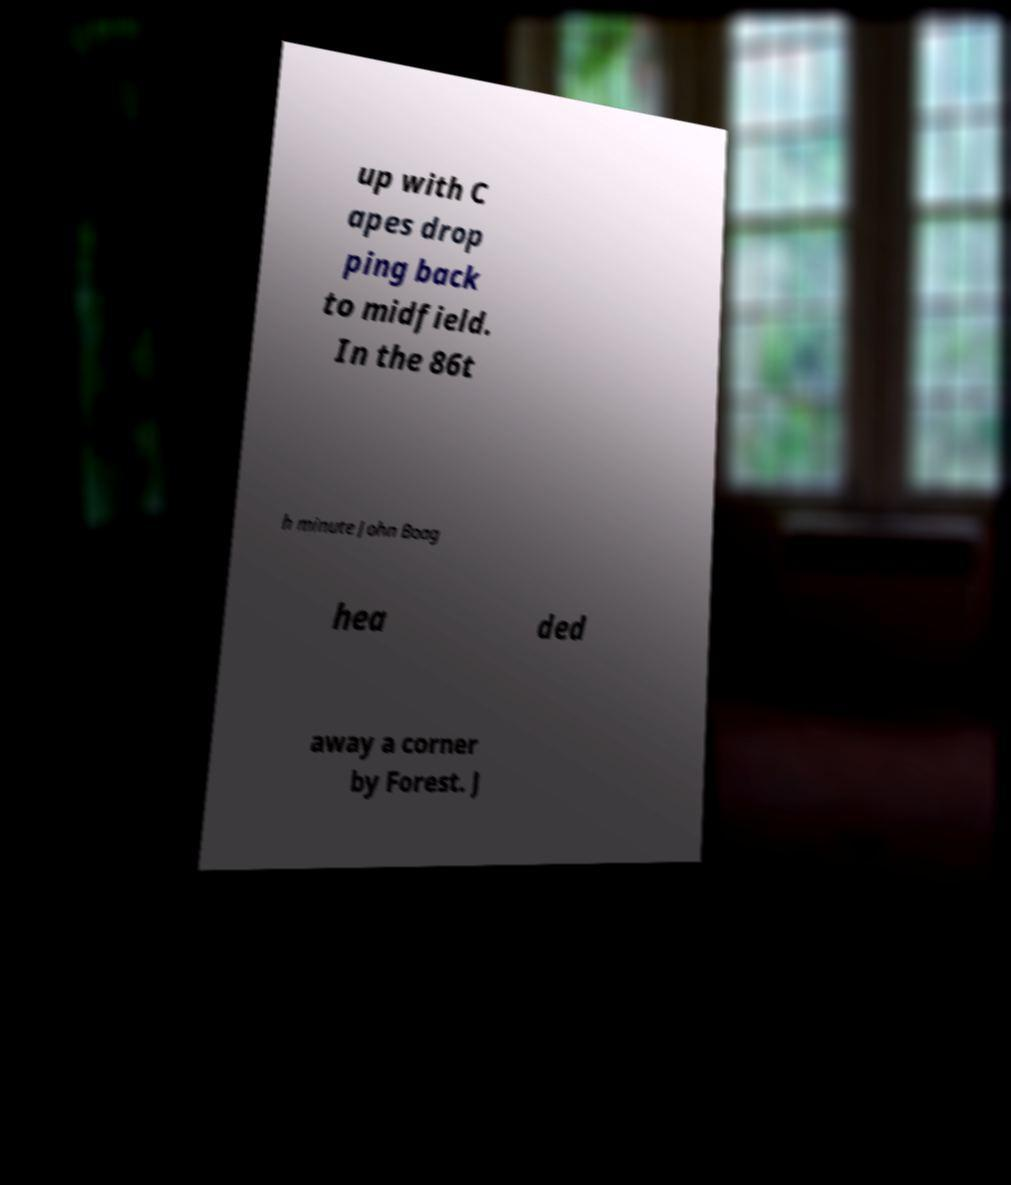Please read and relay the text visible in this image. What does it say? up with C apes drop ping back to midfield. In the 86t h minute John Boag hea ded away a corner by Forest. J 